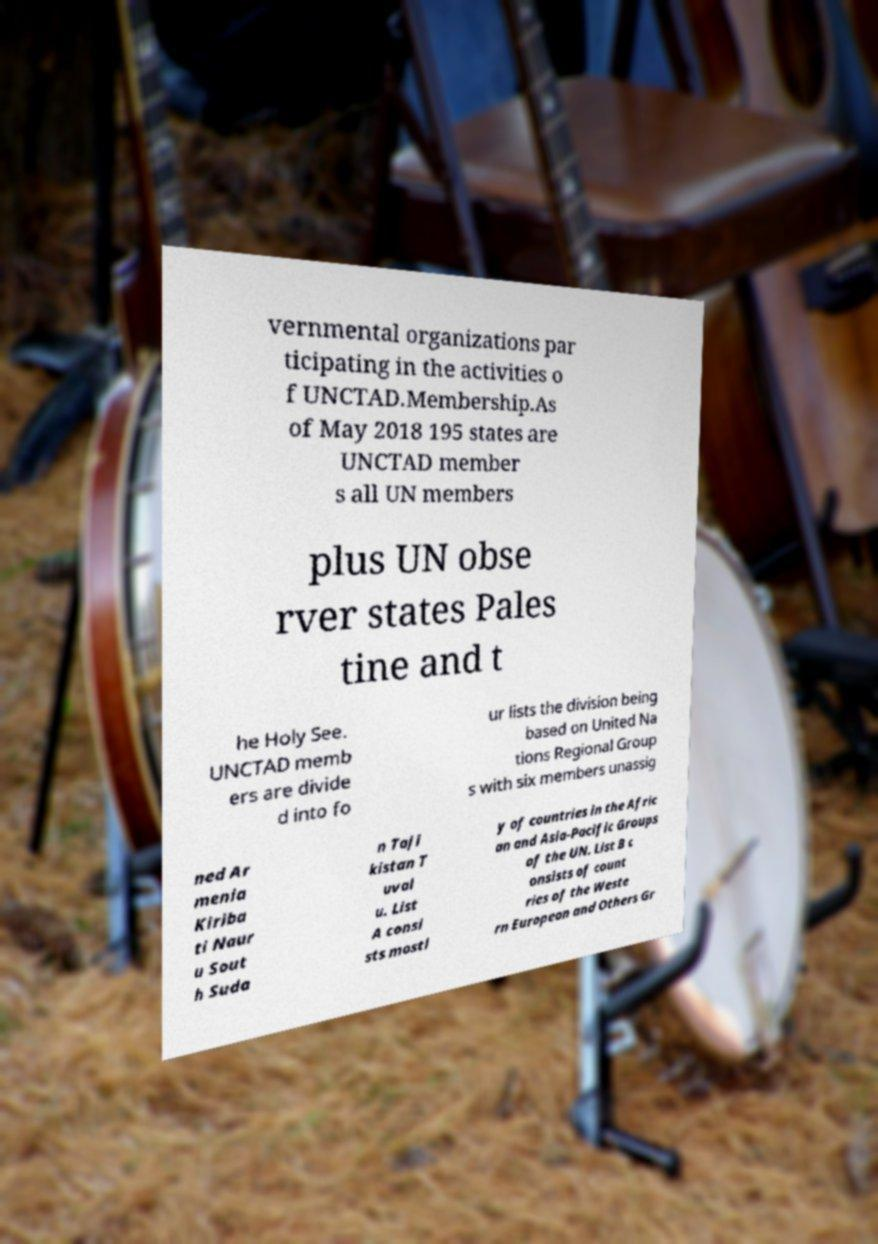There's text embedded in this image that I need extracted. Can you transcribe it verbatim? vernmental organizations par ticipating in the activities o f UNCTAD.Membership.As of May 2018 195 states are UNCTAD member s all UN members plus UN obse rver states Pales tine and t he Holy See. UNCTAD memb ers are divide d into fo ur lists the division being based on United Na tions Regional Group s with six members unassig ned Ar menia Kiriba ti Naur u Sout h Suda n Taji kistan T uval u. List A consi sts mostl y of countries in the Afric an and Asia-Pacific Groups of the UN. List B c onsists of count ries of the Weste rn European and Others Gr 